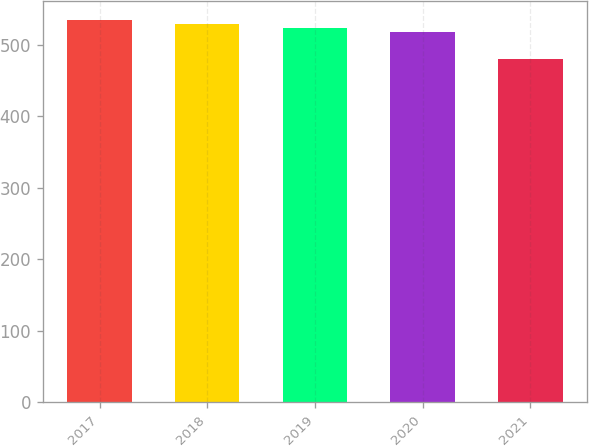<chart> <loc_0><loc_0><loc_500><loc_500><bar_chart><fcel>2017<fcel>2018<fcel>2019<fcel>2020<fcel>2021<nl><fcel>535.2<fcel>529.8<fcel>524.4<fcel>519<fcel>481<nl></chart> 